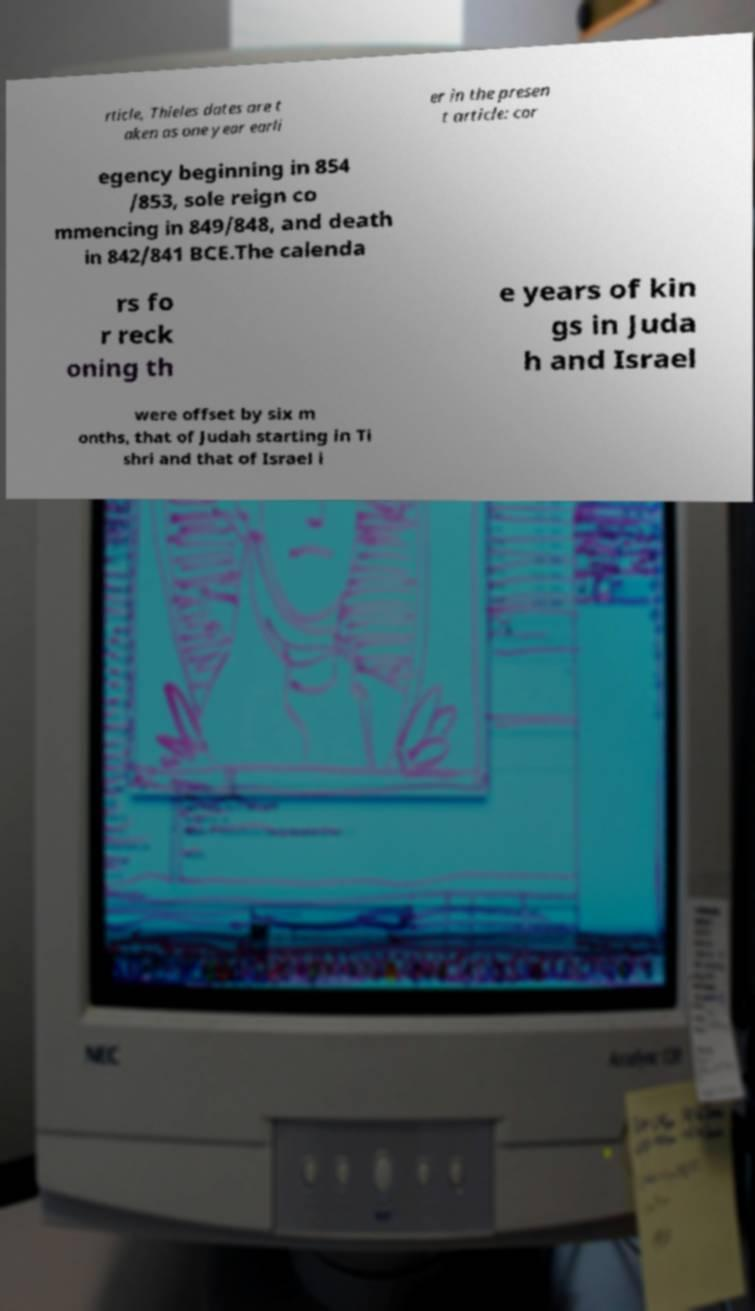Please identify and transcribe the text found in this image. rticle, Thieles dates are t aken as one year earli er in the presen t article: cor egency beginning in 854 /853, sole reign co mmencing in 849/848, and death in 842/841 BCE.The calenda rs fo r reck oning th e years of kin gs in Juda h and Israel were offset by six m onths, that of Judah starting in Ti shri and that of Israel i 